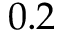<formula> <loc_0><loc_0><loc_500><loc_500>0 . 2</formula> 